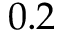<formula> <loc_0><loc_0><loc_500><loc_500>0 . 2</formula> 